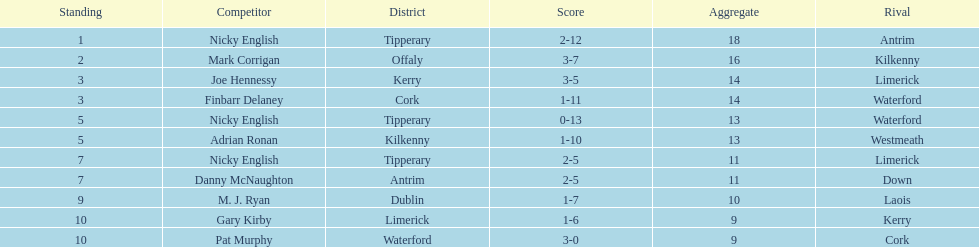Which player ranked the most? Nicky English. 